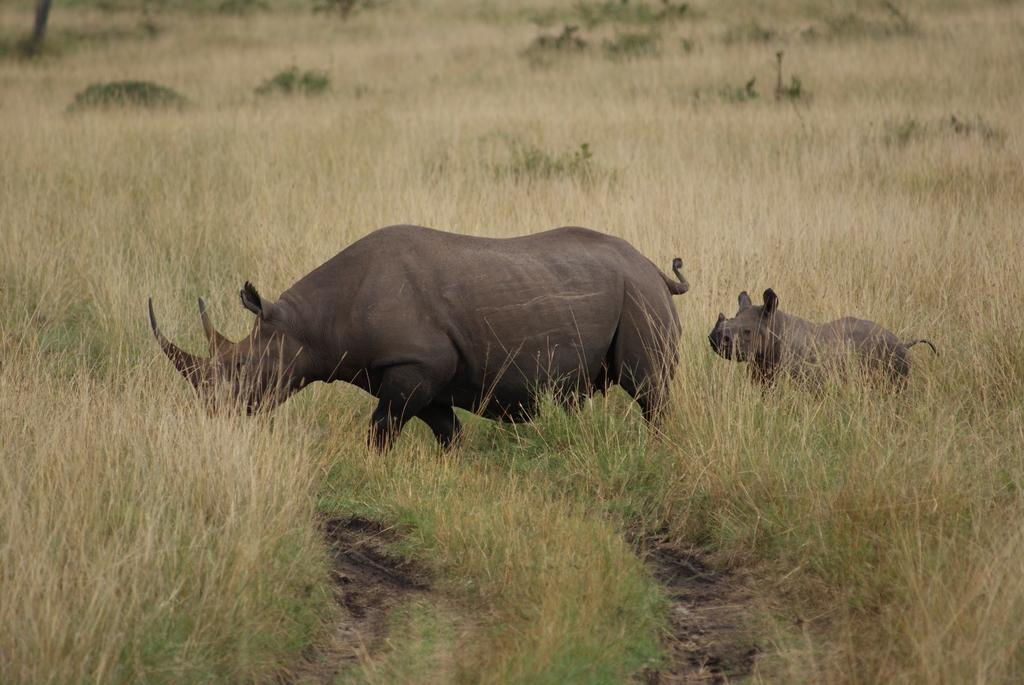What type of surface is visible in the image? There is a grass surface in the image. What animals can be seen in the image? There is a rhinoceros and a baby rhinoceros in the image. What are the rhinoceros and baby rhinoceros doing in the image? Both the rhinoceros and baby rhinoceros are walking on the grass surface. What type of celery is being used to create the paste in the image? There is no celery or paste present in the image; it features a rhinoceros and a baby rhinoceros walking on a grass surface. 